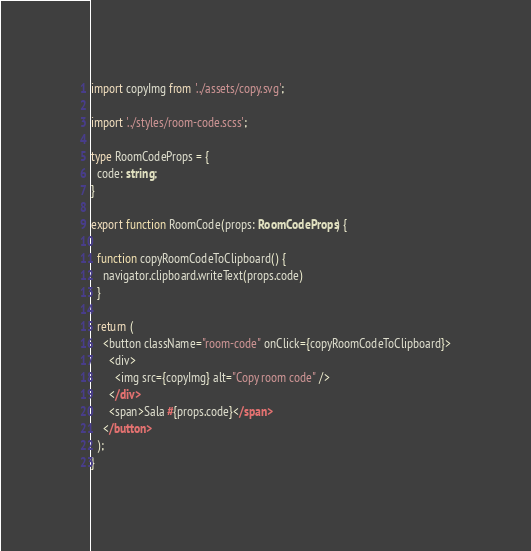Convert code to text. <code><loc_0><loc_0><loc_500><loc_500><_TypeScript_>import copyImg from '../assets/copy.svg';

import '../styles/room-code.scss';

type RoomCodeProps = {
  code: string;
} 

export function RoomCode(props: RoomCodeProps) {

  function copyRoomCodeToClipboard() {
    navigator.clipboard.writeText(props.code)
  }

  return (
    <button className="room-code" onClick={copyRoomCodeToClipboard}>
      <div>
        <img src={copyImg} alt="Copy room code" />
      </div>
      <span>Sala #{props.code}</span>
    </button>
  );
}</code> 